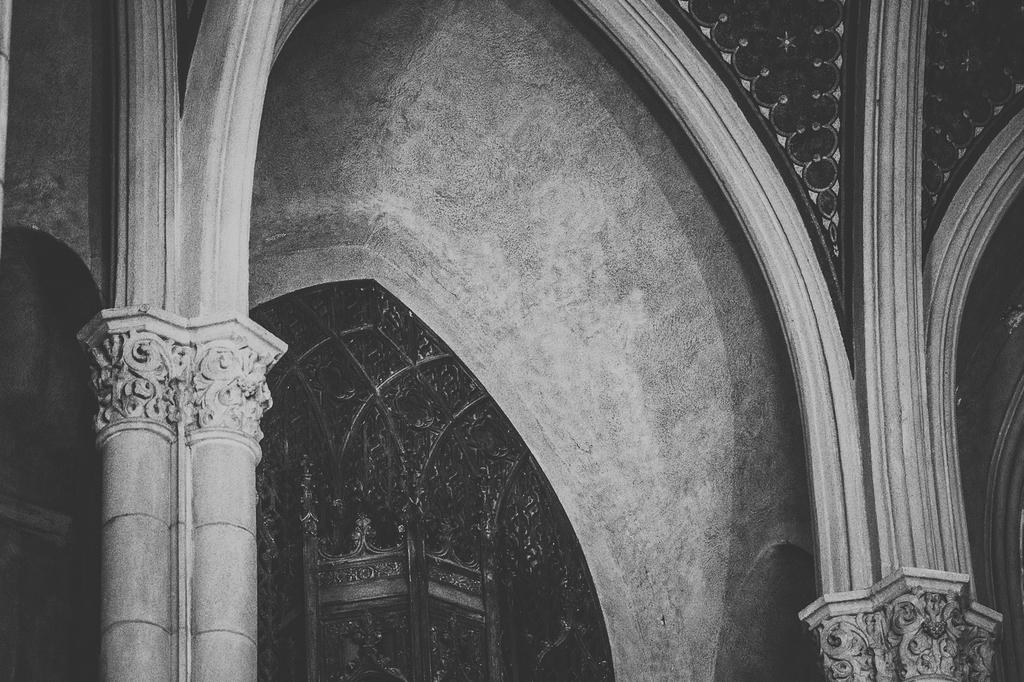What is the color scheme of the image? The image is black and white. What type of location is depicted in the image? The image is an inside view of a building. What architectural features can be seen in the image? There are pillars visible in the image. Can you identify any specific elements of the building's interior? Yes, there is a door, a wall, and a roof in the image. What type of operation is being performed on the wing in the image? There is no wing or operation present in the image; it is an inside view of a building with architectural features and specific elements of the interior. 